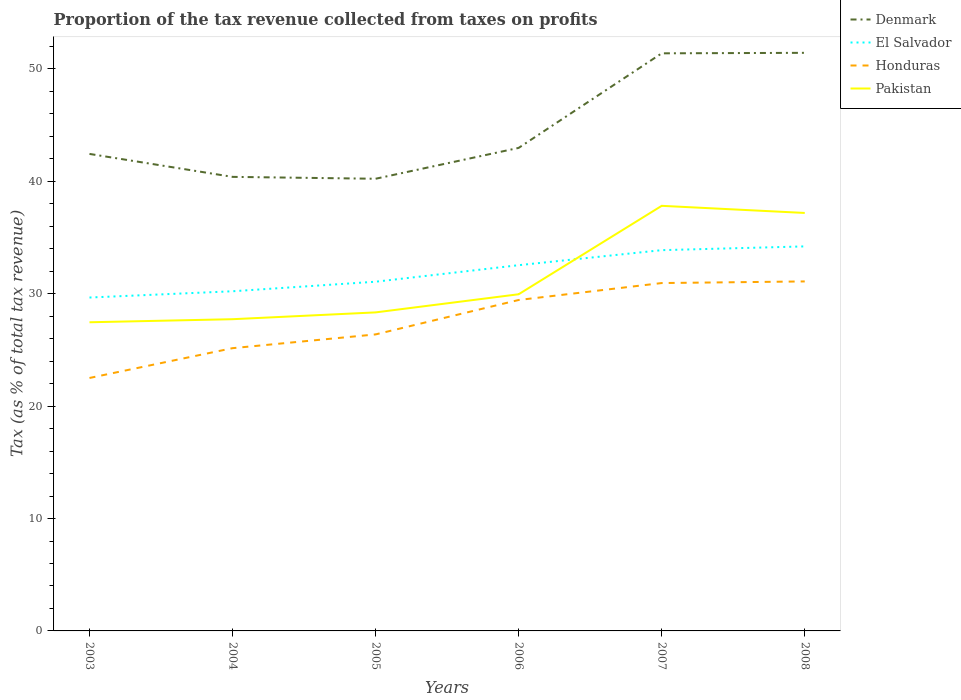How many different coloured lines are there?
Give a very brief answer. 4. Is the number of lines equal to the number of legend labels?
Keep it short and to the point. Yes. Across all years, what is the maximum proportion of the tax revenue collected in Honduras?
Give a very brief answer. 22.51. What is the total proportion of the tax revenue collected in Denmark in the graph?
Offer a very short reply. -8.41. What is the difference between the highest and the second highest proportion of the tax revenue collected in Honduras?
Keep it short and to the point. 8.59. Are the values on the major ticks of Y-axis written in scientific E-notation?
Your answer should be very brief. No. Does the graph contain grids?
Ensure brevity in your answer.  No. What is the title of the graph?
Your response must be concise. Proportion of the tax revenue collected from taxes on profits. Does "Colombia" appear as one of the legend labels in the graph?
Keep it short and to the point. No. What is the label or title of the X-axis?
Your answer should be compact. Years. What is the label or title of the Y-axis?
Keep it short and to the point. Tax (as % of total tax revenue). What is the Tax (as % of total tax revenue) in Denmark in 2003?
Keep it short and to the point. 42.44. What is the Tax (as % of total tax revenue) of El Salvador in 2003?
Provide a short and direct response. 29.66. What is the Tax (as % of total tax revenue) in Honduras in 2003?
Offer a very short reply. 22.51. What is the Tax (as % of total tax revenue) in Pakistan in 2003?
Your answer should be compact. 27.46. What is the Tax (as % of total tax revenue) in Denmark in 2004?
Your answer should be compact. 40.4. What is the Tax (as % of total tax revenue) in El Salvador in 2004?
Provide a short and direct response. 30.22. What is the Tax (as % of total tax revenue) of Honduras in 2004?
Offer a terse response. 25.16. What is the Tax (as % of total tax revenue) of Pakistan in 2004?
Provide a succinct answer. 27.74. What is the Tax (as % of total tax revenue) in Denmark in 2005?
Provide a succinct answer. 40.23. What is the Tax (as % of total tax revenue) in El Salvador in 2005?
Offer a terse response. 31.07. What is the Tax (as % of total tax revenue) in Honduras in 2005?
Your response must be concise. 26.38. What is the Tax (as % of total tax revenue) of Pakistan in 2005?
Your response must be concise. 28.34. What is the Tax (as % of total tax revenue) in Denmark in 2006?
Your answer should be very brief. 42.98. What is the Tax (as % of total tax revenue) in El Salvador in 2006?
Your answer should be compact. 32.54. What is the Tax (as % of total tax revenue) in Honduras in 2006?
Provide a succinct answer. 29.44. What is the Tax (as % of total tax revenue) in Pakistan in 2006?
Make the answer very short. 29.96. What is the Tax (as % of total tax revenue) of Denmark in 2007?
Keep it short and to the point. 51.39. What is the Tax (as % of total tax revenue) of El Salvador in 2007?
Ensure brevity in your answer.  33.88. What is the Tax (as % of total tax revenue) in Honduras in 2007?
Ensure brevity in your answer.  30.95. What is the Tax (as % of total tax revenue) of Pakistan in 2007?
Keep it short and to the point. 37.82. What is the Tax (as % of total tax revenue) of Denmark in 2008?
Your answer should be very brief. 51.44. What is the Tax (as % of total tax revenue) of El Salvador in 2008?
Give a very brief answer. 34.21. What is the Tax (as % of total tax revenue) of Honduras in 2008?
Ensure brevity in your answer.  31.1. What is the Tax (as % of total tax revenue) in Pakistan in 2008?
Ensure brevity in your answer.  37.19. Across all years, what is the maximum Tax (as % of total tax revenue) of Denmark?
Make the answer very short. 51.44. Across all years, what is the maximum Tax (as % of total tax revenue) of El Salvador?
Offer a terse response. 34.21. Across all years, what is the maximum Tax (as % of total tax revenue) of Honduras?
Your answer should be compact. 31.1. Across all years, what is the maximum Tax (as % of total tax revenue) in Pakistan?
Your answer should be compact. 37.82. Across all years, what is the minimum Tax (as % of total tax revenue) of Denmark?
Your response must be concise. 40.23. Across all years, what is the minimum Tax (as % of total tax revenue) of El Salvador?
Ensure brevity in your answer.  29.66. Across all years, what is the minimum Tax (as % of total tax revenue) in Honduras?
Keep it short and to the point. 22.51. Across all years, what is the minimum Tax (as % of total tax revenue) in Pakistan?
Provide a succinct answer. 27.46. What is the total Tax (as % of total tax revenue) in Denmark in the graph?
Give a very brief answer. 268.89. What is the total Tax (as % of total tax revenue) in El Salvador in the graph?
Offer a very short reply. 191.6. What is the total Tax (as % of total tax revenue) of Honduras in the graph?
Your answer should be compact. 165.54. What is the total Tax (as % of total tax revenue) in Pakistan in the graph?
Give a very brief answer. 188.51. What is the difference between the Tax (as % of total tax revenue) of Denmark in 2003 and that in 2004?
Provide a short and direct response. 2.04. What is the difference between the Tax (as % of total tax revenue) of El Salvador in 2003 and that in 2004?
Make the answer very short. -0.56. What is the difference between the Tax (as % of total tax revenue) of Honduras in 2003 and that in 2004?
Ensure brevity in your answer.  -2.65. What is the difference between the Tax (as % of total tax revenue) of Pakistan in 2003 and that in 2004?
Ensure brevity in your answer.  -0.27. What is the difference between the Tax (as % of total tax revenue) in Denmark in 2003 and that in 2005?
Keep it short and to the point. 2.21. What is the difference between the Tax (as % of total tax revenue) of El Salvador in 2003 and that in 2005?
Keep it short and to the point. -1.41. What is the difference between the Tax (as % of total tax revenue) of Honduras in 2003 and that in 2005?
Your answer should be compact. -3.88. What is the difference between the Tax (as % of total tax revenue) of Pakistan in 2003 and that in 2005?
Provide a succinct answer. -0.88. What is the difference between the Tax (as % of total tax revenue) of Denmark in 2003 and that in 2006?
Your answer should be compact. -0.54. What is the difference between the Tax (as % of total tax revenue) in El Salvador in 2003 and that in 2006?
Provide a succinct answer. -2.88. What is the difference between the Tax (as % of total tax revenue) of Honduras in 2003 and that in 2006?
Give a very brief answer. -6.94. What is the difference between the Tax (as % of total tax revenue) in Pakistan in 2003 and that in 2006?
Offer a terse response. -2.49. What is the difference between the Tax (as % of total tax revenue) in Denmark in 2003 and that in 2007?
Offer a very short reply. -8.95. What is the difference between the Tax (as % of total tax revenue) of El Salvador in 2003 and that in 2007?
Make the answer very short. -4.22. What is the difference between the Tax (as % of total tax revenue) in Honduras in 2003 and that in 2007?
Offer a terse response. -8.45. What is the difference between the Tax (as % of total tax revenue) of Pakistan in 2003 and that in 2007?
Offer a very short reply. -10.36. What is the difference between the Tax (as % of total tax revenue) in Denmark in 2003 and that in 2008?
Offer a terse response. -8.99. What is the difference between the Tax (as % of total tax revenue) in El Salvador in 2003 and that in 2008?
Keep it short and to the point. -4.55. What is the difference between the Tax (as % of total tax revenue) of Honduras in 2003 and that in 2008?
Offer a terse response. -8.59. What is the difference between the Tax (as % of total tax revenue) in Pakistan in 2003 and that in 2008?
Provide a short and direct response. -9.73. What is the difference between the Tax (as % of total tax revenue) of Denmark in 2004 and that in 2005?
Provide a short and direct response. 0.17. What is the difference between the Tax (as % of total tax revenue) of El Salvador in 2004 and that in 2005?
Keep it short and to the point. -0.85. What is the difference between the Tax (as % of total tax revenue) of Honduras in 2004 and that in 2005?
Ensure brevity in your answer.  -1.22. What is the difference between the Tax (as % of total tax revenue) in Pakistan in 2004 and that in 2005?
Your answer should be compact. -0.61. What is the difference between the Tax (as % of total tax revenue) of Denmark in 2004 and that in 2006?
Keep it short and to the point. -2.58. What is the difference between the Tax (as % of total tax revenue) of El Salvador in 2004 and that in 2006?
Offer a very short reply. -2.32. What is the difference between the Tax (as % of total tax revenue) of Honduras in 2004 and that in 2006?
Offer a terse response. -4.29. What is the difference between the Tax (as % of total tax revenue) of Pakistan in 2004 and that in 2006?
Provide a short and direct response. -2.22. What is the difference between the Tax (as % of total tax revenue) of Denmark in 2004 and that in 2007?
Offer a terse response. -10.99. What is the difference between the Tax (as % of total tax revenue) of El Salvador in 2004 and that in 2007?
Your answer should be very brief. -3.66. What is the difference between the Tax (as % of total tax revenue) of Honduras in 2004 and that in 2007?
Your response must be concise. -5.79. What is the difference between the Tax (as % of total tax revenue) in Pakistan in 2004 and that in 2007?
Give a very brief answer. -10.09. What is the difference between the Tax (as % of total tax revenue) of Denmark in 2004 and that in 2008?
Give a very brief answer. -11.04. What is the difference between the Tax (as % of total tax revenue) in El Salvador in 2004 and that in 2008?
Keep it short and to the point. -3.99. What is the difference between the Tax (as % of total tax revenue) in Honduras in 2004 and that in 2008?
Ensure brevity in your answer.  -5.94. What is the difference between the Tax (as % of total tax revenue) in Pakistan in 2004 and that in 2008?
Your answer should be very brief. -9.45. What is the difference between the Tax (as % of total tax revenue) in Denmark in 2005 and that in 2006?
Make the answer very short. -2.75. What is the difference between the Tax (as % of total tax revenue) of El Salvador in 2005 and that in 2006?
Offer a very short reply. -1.47. What is the difference between the Tax (as % of total tax revenue) of Honduras in 2005 and that in 2006?
Ensure brevity in your answer.  -3.06. What is the difference between the Tax (as % of total tax revenue) of Pakistan in 2005 and that in 2006?
Provide a short and direct response. -1.61. What is the difference between the Tax (as % of total tax revenue) of Denmark in 2005 and that in 2007?
Make the answer very short. -11.16. What is the difference between the Tax (as % of total tax revenue) of El Salvador in 2005 and that in 2007?
Your answer should be very brief. -2.81. What is the difference between the Tax (as % of total tax revenue) of Honduras in 2005 and that in 2007?
Your answer should be compact. -4.57. What is the difference between the Tax (as % of total tax revenue) of Pakistan in 2005 and that in 2007?
Provide a short and direct response. -9.48. What is the difference between the Tax (as % of total tax revenue) of Denmark in 2005 and that in 2008?
Provide a short and direct response. -11.2. What is the difference between the Tax (as % of total tax revenue) of El Salvador in 2005 and that in 2008?
Provide a succinct answer. -3.14. What is the difference between the Tax (as % of total tax revenue) in Honduras in 2005 and that in 2008?
Offer a terse response. -4.71. What is the difference between the Tax (as % of total tax revenue) in Pakistan in 2005 and that in 2008?
Ensure brevity in your answer.  -8.85. What is the difference between the Tax (as % of total tax revenue) of Denmark in 2006 and that in 2007?
Keep it short and to the point. -8.41. What is the difference between the Tax (as % of total tax revenue) of El Salvador in 2006 and that in 2007?
Your answer should be very brief. -1.34. What is the difference between the Tax (as % of total tax revenue) in Honduras in 2006 and that in 2007?
Offer a very short reply. -1.51. What is the difference between the Tax (as % of total tax revenue) in Pakistan in 2006 and that in 2007?
Your answer should be compact. -7.87. What is the difference between the Tax (as % of total tax revenue) in Denmark in 2006 and that in 2008?
Offer a terse response. -8.46. What is the difference between the Tax (as % of total tax revenue) of El Salvador in 2006 and that in 2008?
Ensure brevity in your answer.  -1.67. What is the difference between the Tax (as % of total tax revenue) of Honduras in 2006 and that in 2008?
Your answer should be compact. -1.65. What is the difference between the Tax (as % of total tax revenue) of Pakistan in 2006 and that in 2008?
Make the answer very short. -7.23. What is the difference between the Tax (as % of total tax revenue) of Denmark in 2007 and that in 2008?
Your answer should be compact. -0.04. What is the difference between the Tax (as % of total tax revenue) of El Salvador in 2007 and that in 2008?
Make the answer very short. -0.33. What is the difference between the Tax (as % of total tax revenue) in Honduras in 2007 and that in 2008?
Ensure brevity in your answer.  -0.15. What is the difference between the Tax (as % of total tax revenue) in Pakistan in 2007 and that in 2008?
Your answer should be compact. 0.63. What is the difference between the Tax (as % of total tax revenue) of Denmark in 2003 and the Tax (as % of total tax revenue) of El Salvador in 2004?
Offer a terse response. 12.22. What is the difference between the Tax (as % of total tax revenue) of Denmark in 2003 and the Tax (as % of total tax revenue) of Honduras in 2004?
Your response must be concise. 17.28. What is the difference between the Tax (as % of total tax revenue) in Denmark in 2003 and the Tax (as % of total tax revenue) in Pakistan in 2004?
Your answer should be very brief. 14.71. What is the difference between the Tax (as % of total tax revenue) of El Salvador in 2003 and the Tax (as % of total tax revenue) of Honduras in 2004?
Give a very brief answer. 4.51. What is the difference between the Tax (as % of total tax revenue) in El Salvador in 2003 and the Tax (as % of total tax revenue) in Pakistan in 2004?
Keep it short and to the point. 1.93. What is the difference between the Tax (as % of total tax revenue) in Honduras in 2003 and the Tax (as % of total tax revenue) in Pakistan in 2004?
Your answer should be compact. -5.23. What is the difference between the Tax (as % of total tax revenue) in Denmark in 2003 and the Tax (as % of total tax revenue) in El Salvador in 2005?
Keep it short and to the point. 11.37. What is the difference between the Tax (as % of total tax revenue) of Denmark in 2003 and the Tax (as % of total tax revenue) of Honduras in 2005?
Your response must be concise. 16.06. What is the difference between the Tax (as % of total tax revenue) of Denmark in 2003 and the Tax (as % of total tax revenue) of Pakistan in 2005?
Offer a very short reply. 14.1. What is the difference between the Tax (as % of total tax revenue) in El Salvador in 2003 and the Tax (as % of total tax revenue) in Honduras in 2005?
Make the answer very short. 3.28. What is the difference between the Tax (as % of total tax revenue) in El Salvador in 2003 and the Tax (as % of total tax revenue) in Pakistan in 2005?
Offer a very short reply. 1.32. What is the difference between the Tax (as % of total tax revenue) of Honduras in 2003 and the Tax (as % of total tax revenue) of Pakistan in 2005?
Ensure brevity in your answer.  -5.84. What is the difference between the Tax (as % of total tax revenue) of Denmark in 2003 and the Tax (as % of total tax revenue) of El Salvador in 2006?
Provide a succinct answer. 9.9. What is the difference between the Tax (as % of total tax revenue) in Denmark in 2003 and the Tax (as % of total tax revenue) in Honduras in 2006?
Your answer should be very brief. 13. What is the difference between the Tax (as % of total tax revenue) in Denmark in 2003 and the Tax (as % of total tax revenue) in Pakistan in 2006?
Keep it short and to the point. 12.49. What is the difference between the Tax (as % of total tax revenue) in El Salvador in 2003 and the Tax (as % of total tax revenue) in Honduras in 2006?
Keep it short and to the point. 0.22. What is the difference between the Tax (as % of total tax revenue) in El Salvador in 2003 and the Tax (as % of total tax revenue) in Pakistan in 2006?
Offer a terse response. -0.29. What is the difference between the Tax (as % of total tax revenue) in Honduras in 2003 and the Tax (as % of total tax revenue) in Pakistan in 2006?
Your answer should be very brief. -7.45. What is the difference between the Tax (as % of total tax revenue) in Denmark in 2003 and the Tax (as % of total tax revenue) in El Salvador in 2007?
Make the answer very short. 8.56. What is the difference between the Tax (as % of total tax revenue) of Denmark in 2003 and the Tax (as % of total tax revenue) of Honduras in 2007?
Give a very brief answer. 11.49. What is the difference between the Tax (as % of total tax revenue) of Denmark in 2003 and the Tax (as % of total tax revenue) of Pakistan in 2007?
Make the answer very short. 4.62. What is the difference between the Tax (as % of total tax revenue) in El Salvador in 2003 and the Tax (as % of total tax revenue) in Honduras in 2007?
Your answer should be compact. -1.29. What is the difference between the Tax (as % of total tax revenue) of El Salvador in 2003 and the Tax (as % of total tax revenue) of Pakistan in 2007?
Keep it short and to the point. -8.16. What is the difference between the Tax (as % of total tax revenue) of Honduras in 2003 and the Tax (as % of total tax revenue) of Pakistan in 2007?
Your answer should be very brief. -15.32. What is the difference between the Tax (as % of total tax revenue) in Denmark in 2003 and the Tax (as % of total tax revenue) in El Salvador in 2008?
Your answer should be compact. 8.23. What is the difference between the Tax (as % of total tax revenue) of Denmark in 2003 and the Tax (as % of total tax revenue) of Honduras in 2008?
Provide a short and direct response. 11.35. What is the difference between the Tax (as % of total tax revenue) in Denmark in 2003 and the Tax (as % of total tax revenue) in Pakistan in 2008?
Your response must be concise. 5.25. What is the difference between the Tax (as % of total tax revenue) of El Salvador in 2003 and the Tax (as % of total tax revenue) of Honduras in 2008?
Ensure brevity in your answer.  -1.43. What is the difference between the Tax (as % of total tax revenue) of El Salvador in 2003 and the Tax (as % of total tax revenue) of Pakistan in 2008?
Ensure brevity in your answer.  -7.53. What is the difference between the Tax (as % of total tax revenue) of Honduras in 2003 and the Tax (as % of total tax revenue) of Pakistan in 2008?
Provide a succinct answer. -14.68. What is the difference between the Tax (as % of total tax revenue) in Denmark in 2004 and the Tax (as % of total tax revenue) in El Salvador in 2005?
Give a very brief answer. 9.33. What is the difference between the Tax (as % of total tax revenue) in Denmark in 2004 and the Tax (as % of total tax revenue) in Honduras in 2005?
Keep it short and to the point. 14.02. What is the difference between the Tax (as % of total tax revenue) of Denmark in 2004 and the Tax (as % of total tax revenue) of Pakistan in 2005?
Your answer should be compact. 12.06. What is the difference between the Tax (as % of total tax revenue) of El Salvador in 2004 and the Tax (as % of total tax revenue) of Honduras in 2005?
Provide a short and direct response. 3.84. What is the difference between the Tax (as % of total tax revenue) in El Salvador in 2004 and the Tax (as % of total tax revenue) in Pakistan in 2005?
Offer a very short reply. 1.88. What is the difference between the Tax (as % of total tax revenue) of Honduras in 2004 and the Tax (as % of total tax revenue) of Pakistan in 2005?
Your answer should be compact. -3.18. What is the difference between the Tax (as % of total tax revenue) in Denmark in 2004 and the Tax (as % of total tax revenue) in El Salvador in 2006?
Make the answer very short. 7.86. What is the difference between the Tax (as % of total tax revenue) of Denmark in 2004 and the Tax (as % of total tax revenue) of Honduras in 2006?
Your answer should be compact. 10.96. What is the difference between the Tax (as % of total tax revenue) in Denmark in 2004 and the Tax (as % of total tax revenue) in Pakistan in 2006?
Your answer should be compact. 10.45. What is the difference between the Tax (as % of total tax revenue) in El Salvador in 2004 and the Tax (as % of total tax revenue) in Honduras in 2006?
Give a very brief answer. 0.78. What is the difference between the Tax (as % of total tax revenue) in El Salvador in 2004 and the Tax (as % of total tax revenue) in Pakistan in 2006?
Give a very brief answer. 0.27. What is the difference between the Tax (as % of total tax revenue) of Honduras in 2004 and the Tax (as % of total tax revenue) of Pakistan in 2006?
Provide a succinct answer. -4.8. What is the difference between the Tax (as % of total tax revenue) in Denmark in 2004 and the Tax (as % of total tax revenue) in El Salvador in 2007?
Ensure brevity in your answer.  6.52. What is the difference between the Tax (as % of total tax revenue) of Denmark in 2004 and the Tax (as % of total tax revenue) of Honduras in 2007?
Provide a succinct answer. 9.45. What is the difference between the Tax (as % of total tax revenue) of Denmark in 2004 and the Tax (as % of total tax revenue) of Pakistan in 2007?
Your answer should be compact. 2.58. What is the difference between the Tax (as % of total tax revenue) of El Salvador in 2004 and the Tax (as % of total tax revenue) of Honduras in 2007?
Provide a short and direct response. -0.73. What is the difference between the Tax (as % of total tax revenue) of El Salvador in 2004 and the Tax (as % of total tax revenue) of Pakistan in 2007?
Your answer should be compact. -7.6. What is the difference between the Tax (as % of total tax revenue) in Honduras in 2004 and the Tax (as % of total tax revenue) in Pakistan in 2007?
Offer a terse response. -12.67. What is the difference between the Tax (as % of total tax revenue) in Denmark in 2004 and the Tax (as % of total tax revenue) in El Salvador in 2008?
Your answer should be very brief. 6.19. What is the difference between the Tax (as % of total tax revenue) in Denmark in 2004 and the Tax (as % of total tax revenue) in Honduras in 2008?
Provide a succinct answer. 9.3. What is the difference between the Tax (as % of total tax revenue) in Denmark in 2004 and the Tax (as % of total tax revenue) in Pakistan in 2008?
Offer a terse response. 3.21. What is the difference between the Tax (as % of total tax revenue) of El Salvador in 2004 and the Tax (as % of total tax revenue) of Honduras in 2008?
Offer a terse response. -0.88. What is the difference between the Tax (as % of total tax revenue) of El Salvador in 2004 and the Tax (as % of total tax revenue) of Pakistan in 2008?
Ensure brevity in your answer.  -6.97. What is the difference between the Tax (as % of total tax revenue) in Honduras in 2004 and the Tax (as % of total tax revenue) in Pakistan in 2008?
Make the answer very short. -12.03. What is the difference between the Tax (as % of total tax revenue) of Denmark in 2005 and the Tax (as % of total tax revenue) of El Salvador in 2006?
Give a very brief answer. 7.69. What is the difference between the Tax (as % of total tax revenue) in Denmark in 2005 and the Tax (as % of total tax revenue) in Honduras in 2006?
Your answer should be very brief. 10.79. What is the difference between the Tax (as % of total tax revenue) of Denmark in 2005 and the Tax (as % of total tax revenue) of Pakistan in 2006?
Offer a very short reply. 10.28. What is the difference between the Tax (as % of total tax revenue) in El Salvador in 2005 and the Tax (as % of total tax revenue) in Honduras in 2006?
Your answer should be compact. 1.63. What is the difference between the Tax (as % of total tax revenue) of El Salvador in 2005 and the Tax (as % of total tax revenue) of Pakistan in 2006?
Provide a succinct answer. 1.12. What is the difference between the Tax (as % of total tax revenue) of Honduras in 2005 and the Tax (as % of total tax revenue) of Pakistan in 2006?
Make the answer very short. -3.57. What is the difference between the Tax (as % of total tax revenue) of Denmark in 2005 and the Tax (as % of total tax revenue) of El Salvador in 2007?
Your answer should be very brief. 6.35. What is the difference between the Tax (as % of total tax revenue) of Denmark in 2005 and the Tax (as % of total tax revenue) of Honduras in 2007?
Make the answer very short. 9.28. What is the difference between the Tax (as % of total tax revenue) in Denmark in 2005 and the Tax (as % of total tax revenue) in Pakistan in 2007?
Offer a very short reply. 2.41. What is the difference between the Tax (as % of total tax revenue) of El Salvador in 2005 and the Tax (as % of total tax revenue) of Honduras in 2007?
Your answer should be very brief. 0.12. What is the difference between the Tax (as % of total tax revenue) of El Salvador in 2005 and the Tax (as % of total tax revenue) of Pakistan in 2007?
Your answer should be compact. -6.75. What is the difference between the Tax (as % of total tax revenue) in Honduras in 2005 and the Tax (as % of total tax revenue) in Pakistan in 2007?
Keep it short and to the point. -11.44. What is the difference between the Tax (as % of total tax revenue) in Denmark in 2005 and the Tax (as % of total tax revenue) in El Salvador in 2008?
Your answer should be compact. 6.02. What is the difference between the Tax (as % of total tax revenue) in Denmark in 2005 and the Tax (as % of total tax revenue) in Honduras in 2008?
Your response must be concise. 9.13. What is the difference between the Tax (as % of total tax revenue) in Denmark in 2005 and the Tax (as % of total tax revenue) in Pakistan in 2008?
Offer a terse response. 3.04. What is the difference between the Tax (as % of total tax revenue) in El Salvador in 2005 and the Tax (as % of total tax revenue) in Honduras in 2008?
Give a very brief answer. -0.03. What is the difference between the Tax (as % of total tax revenue) of El Salvador in 2005 and the Tax (as % of total tax revenue) of Pakistan in 2008?
Your response must be concise. -6.12. What is the difference between the Tax (as % of total tax revenue) in Honduras in 2005 and the Tax (as % of total tax revenue) in Pakistan in 2008?
Keep it short and to the point. -10.81. What is the difference between the Tax (as % of total tax revenue) of Denmark in 2006 and the Tax (as % of total tax revenue) of El Salvador in 2007?
Your answer should be compact. 9.1. What is the difference between the Tax (as % of total tax revenue) of Denmark in 2006 and the Tax (as % of total tax revenue) of Honduras in 2007?
Make the answer very short. 12.03. What is the difference between the Tax (as % of total tax revenue) in Denmark in 2006 and the Tax (as % of total tax revenue) in Pakistan in 2007?
Ensure brevity in your answer.  5.16. What is the difference between the Tax (as % of total tax revenue) in El Salvador in 2006 and the Tax (as % of total tax revenue) in Honduras in 2007?
Ensure brevity in your answer.  1.59. What is the difference between the Tax (as % of total tax revenue) in El Salvador in 2006 and the Tax (as % of total tax revenue) in Pakistan in 2007?
Offer a very short reply. -5.28. What is the difference between the Tax (as % of total tax revenue) of Honduras in 2006 and the Tax (as % of total tax revenue) of Pakistan in 2007?
Make the answer very short. -8.38. What is the difference between the Tax (as % of total tax revenue) of Denmark in 2006 and the Tax (as % of total tax revenue) of El Salvador in 2008?
Provide a succinct answer. 8.76. What is the difference between the Tax (as % of total tax revenue) in Denmark in 2006 and the Tax (as % of total tax revenue) in Honduras in 2008?
Provide a short and direct response. 11.88. What is the difference between the Tax (as % of total tax revenue) of Denmark in 2006 and the Tax (as % of total tax revenue) of Pakistan in 2008?
Ensure brevity in your answer.  5.79. What is the difference between the Tax (as % of total tax revenue) of El Salvador in 2006 and the Tax (as % of total tax revenue) of Honduras in 2008?
Give a very brief answer. 1.44. What is the difference between the Tax (as % of total tax revenue) in El Salvador in 2006 and the Tax (as % of total tax revenue) in Pakistan in 2008?
Give a very brief answer. -4.65. What is the difference between the Tax (as % of total tax revenue) in Honduras in 2006 and the Tax (as % of total tax revenue) in Pakistan in 2008?
Make the answer very short. -7.74. What is the difference between the Tax (as % of total tax revenue) in Denmark in 2007 and the Tax (as % of total tax revenue) in El Salvador in 2008?
Make the answer very short. 17.18. What is the difference between the Tax (as % of total tax revenue) of Denmark in 2007 and the Tax (as % of total tax revenue) of Honduras in 2008?
Provide a succinct answer. 20.3. What is the difference between the Tax (as % of total tax revenue) in Denmark in 2007 and the Tax (as % of total tax revenue) in Pakistan in 2008?
Your response must be concise. 14.2. What is the difference between the Tax (as % of total tax revenue) in El Salvador in 2007 and the Tax (as % of total tax revenue) in Honduras in 2008?
Your answer should be very brief. 2.78. What is the difference between the Tax (as % of total tax revenue) in El Salvador in 2007 and the Tax (as % of total tax revenue) in Pakistan in 2008?
Keep it short and to the point. -3.31. What is the difference between the Tax (as % of total tax revenue) of Honduras in 2007 and the Tax (as % of total tax revenue) of Pakistan in 2008?
Your answer should be compact. -6.24. What is the average Tax (as % of total tax revenue) in Denmark per year?
Your answer should be very brief. 44.81. What is the average Tax (as % of total tax revenue) of El Salvador per year?
Your answer should be very brief. 31.93. What is the average Tax (as % of total tax revenue) in Honduras per year?
Ensure brevity in your answer.  27.59. What is the average Tax (as % of total tax revenue) in Pakistan per year?
Provide a succinct answer. 31.42. In the year 2003, what is the difference between the Tax (as % of total tax revenue) in Denmark and Tax (as % of total tax revenue) in El Salvador?
Offer a very short reply. 12.78. In the year 2003, what is the difference between the Tax (as % of total tax revenue) of Denmark and Tax (as % of total tax revenue) of Honduras?
Make the answer very short. 19.94. In the year 2003, what is the difference between the Tax (as % of total tax revenue) in Denmark and Tax (as % of total tax revenue) in Pakistan?
Provide a succinct answer. 14.98. In the year 2003, what is the difference between the Tax (as % of total tax revenue) in El Salvador and Tax (as % of total tax revenue) in Honduras?
Keep it short and to the point. 7.16. In the year 2003, what is the difference between the Tax (as % of total tax revenue) in El Salvador and Tax (as % of total tax revenue) in Pakistan?
Make the answer very short. 2.2. In the year 2003, what is the difference between the Tax (as % of total tax revenue) of Honduras and Tax (as % of total tax revenue) of Pakistan?
Provide a short and direct response. -4.96. In the year 2004, what is the difference between the Tax (as % of total tax revenue) of Denmark and Tax (as % of total tax revenue) of El Salvador?
Make the answer very short. 10.18. In the year 2004, what is the difference between the Tax (as % of total tax revenue) of Denmark and Tax (as % of total tax revenue) of Honduras?
Your response must be concise. 15.24. In the year 2004, what is the difference between the Tax (as % of total tax revenue) in Denmark and Tax (as % of total tax revenue) in Pakistan?
Your answer should be compact. 12.66. In the year 2004, what is the difference between the Tax (as % of total tax revenue) of El Salvador and Tax (as % of total tax revenue) of Honduras?
Ensure brevity in your answer.  5.06. In the year 2004, what is the difference between the Tax (as % of total tax revenue) of El Salvador and Tax (as % of total tax revenue) of Pakistan?
Your answer should be compact. 2.49. In the year 2004, what is the difference between the Tax (as % of total tax revenue) of Honduras and Tax (as % of total tax revenue) of Pakistan?
Provide a succinct answer. -2.58. In the year 2005, what is the difference between the Tax (as % of total tax revenue) of Denmark and Tax (as % of total tax revenue) of El Salvador?
Provide a short and direct response. 9.16. In the year 2005, what is the difference between the Tax (as % of total tax revenue) in Denmark and Tax (as % of total tax revenue) in Honduras?
Provide a short and direct response. 13.85. In the year 2005, what is the difference between the Tax (as % of total tax revenue) in Denmark and Tax (as % of total tax revenue) in Pakistan?
Ensure brevity in your answer.  11.89. In the year 2005, what is the difference between the Tax (as % of total tax revenue) of El Salvador and Tax (as % of total tax revenue) of Honduras?
Offer a very short reply. 4.69. In the year 2005, what is the difference between the Tax (as % of total tax revenue) in El Salvador and Tax (as % of total tax revenue) in Pakistan?
Provide a short and direct response. 2.73. In the year 2005, what is the difference between the Tax (as % of total tax revenue) of Honduras and Tax (as % of total tax revenue) of Pakistan?
Keep it short and to the point. -1.96. In the year 2006, what is the difference between the Tax (as % of total tax revenue) in Denmark and Tax (as % of total tax revenue) in El Salvador?
Provide a succinct answer. 10.44. In the year 2006, what is the difference between the Tax (as % of total tax revenue) of Denmark and Tax (as % of total tax revenue) of Honduras?
Offer a very short reply. 13.53. In the year 2006, what is the difference between the Tax (as % of total tax revenue) in Denmark and Tax (as % of total tax revenue) in Pakistan?
Keep it short and to the point. 13.02. In the year 2006, what is the difference between the Tax (as % of total tax revenue) in El Salvador and Tax (as % of total tax revenue) in Honduras?
Offer a very short reply. 3.1. In the year 2006, what is the difference between the Tax (as % of total tax revenue) in El Salvador and Tax (as % of total tax revenue) in Pakistan?
Offer a terse response. 2.59. In the year 2006, what is the difference between the Tax (as % of total tax revenue) of Honduras and Tax (as % of total tax revenue) of Pakistan?
Make the answer very short. -0.51. In the year 2007, what is the difference between the Tax (as % of total tax revenue) in Denmark and Tax (as % of total tax revenue) in El Salvador?
Offer a very short reply. 17.51. In the year 2007, what is the difference between the Tax (as % of total tax revenue) in Denmark and Tax (as % of total tax revenue) in Honduras?
Give a very brief answer. 20.44. In the year 2007, what is the difference between the Tax (as % of total tax revenue) in Denmark and Tax (as % of total tax revenue) in Pakistan?
Your answer should be very brief. 13.57. In the year 2007, what is the difference between the Tax (as % of total tax revenue) in El Salvador and Tax (as % of total tax revenue) in Honduras?
Your answer should be compact. 2.93. In the year 2007, what is the difference between the Tax (as % of total tax revenue) of El Salvador and Tax (as % of total tax revenue) of Pakistan?
Give a very brief answer. -3.94. In the year 2007, what is the difference between the Tax (as % of total tax revenue) in Honduras and Tax (as % of total tax revenue) in Pakistan?
Your response must be concise. -6.87. In the year 2008, what is the difference between the Tax (as % of total tax revenue) in Denmark and Tax (as % of total tax revenue) in El Salvador?
Ensure brevity in your answer.  17.22. In the year 2008, what is the difference between the Tax (as % of total tax revenue) of Denmark and Tax (as % of total tax revenue) of Honduras?
Offer a very short reply. 20.34. In the year 2008, what is the difference between the Tax (as % of total tax revenue) in Denmark and Tax (as % of total tax revenue) in Pakistan?
Provide a short and direct response. 14.25. In the year 2008, what is the difference between the Tax (as % of total tax revenue) of El Salvador and Tax (as % of total tax revenue) of Honduras?
Make the answer very short. 3.12. In the year 2008, what is the difference between the Tax (as % of total tax revenue) in El Salvador and Tax (as % of total tax revenue) in Pakistan?
Ensure brevity in your answer.  -2.98. In the year 2008, what is the difference between the Tax (as % of total tax revenue) in Honduras and Tax (as % of total tax revenue) in Pakistan?
Offer a terse response. -6.09. What is the ratio of the Tax (as % of total tax revenue) of Denmark in 2003 to that in 2004?
Offer a terse response. 1.05. What is the ratio of the Tax (as % of total tax revenue) of El Salvador in 2003 to that in 2004?
Offer a terse response. 0.98. What is the ratio of the Tax (as % of total tax revenue) in Honduras in 2003 to that in 2004?
Give a very brief answer. 0.89. What is the ratio of the Tax (as % of total tax revenue) in Pakistan in 2003 to that in 2004?
Make the answer very short. 0.99. What is the ratio of the Tax (as % of total tax revenue) in Denmark in 2003 to that in 2005?
Provide a short and direct response. 1.05. What is the ratio of the Tax (as % of total tax revenue) in El Salvador in 2003 to that in 2005?
Make the answer very short. 0.95. What is the ratio of the Tax (as % of total tax revenue) in Honduras in 2003 to that in 2005?
Provide a short and direct response. 0.85. What is the ratio of the Tax (as % of total tax revenue) in Pakistan in 2003 to that in 2005?
Your answer should be compact. 0.97. What is the ratio of the Tax (as % of total tax revenue) of Denmark in 2003 to that in 2006?
Offer a very short reply. 0.99. What is the ratio of the Tax (as % of total tax revenue) of El Salvador in 2003 to that in 2006?
Provide a succinct answer. 0.91. What is the ratio of the Tax (as % of total tax revenue) of Honduras in 2003 to that in 2006?
Keep it short and to the point. 0.76. What is the ratio of the Tax (as % of total tax revenue) of Pakistan in 2003 to that in 2006?
Give a very brief answer. 0.92. What is the ratio of the Tax (as % of total tax revenue) in Denmark in 2003 to that in 2007?
Offer a very short reply. 0.83. What is the ratio of the Tax (as % of total tax revenue) of El Salvador in 2003 to that in 2007?
Your answer should be very brief. 0.88. What is the ratio of the Tax (as % of total tax revenue) of Honduras in 2003 to that in 2007?
Ensure brevity in your answer.  0.73. What is the ratio of the Tax (as % of total tax revenue) in Pakistan in 2003 to that in 2007?
Ensure brevity in your answer.  0.73. What is the ratio of the Tax (as % of total tax revenue) in Denmark in 2003 to that in 2008?
Keep it short and to the point. 0.83. What is the ratio of the Tax (as % of total tax revenue) in El Salvador in 2003 to that in 2008?
Offer a very short reply. 0.87. What is the ratio of the Tax (as % of total tax revenue) of Honduras in 2003 to that in 2008?
Your answer should be very brief. 0.72. What is the ratio of the Tax (as % of total tax revenue) in Pakistan in 2003 to that in 2008?
Ensure brevity in your answer.  0.74. What is the ratio of the Tax (as % of total tax revenue) in El Salvador in 2004 to that in 2005?
Keep it short and to the point. 0.97. What is the ratio of the Tax (as % of total tax revenue) in Honduras in 2004 to that in 2005?
Your response must be concise. 0.95. What is the ratio of the Tax (as % of total tax revenue) of Pakistan in 2004 to that in 2005?
Give a very brief answer. 0.98. What is the ratio of the Tax (as % of total tax revenue) in El Salvador in 2004 to that in 2006?
Make the answer very short. 0.93. What is the ratio of the Tax (as % of total tax revenue) of Honduras in 2004 to that in 2006?
Keep it short and to the point. 0.85. What is the ratio of the Tax (as % of total tax revenue) of Pakistan in 2004 to that in 2006?
Offer a very short reply. 0.93. What is the ratio of the Tax (as % of total tax revenue) in Denmark in 2004 to that in 2007?
Make the answer very short. 0.79. What is the ratio of the Tax (as % of total tax revenue) of El Salvador in 2004 to that in 2007?
Provide a short and direct response. 0.89. What is the ratio of the Tax (as % of total tax revenue) in Honduras in 2004 to that in 2007?
Offer a terse response. 0.81. What is the ratio of the Tax (as % of total tax revenue) in Pakistan in 2004 to that in 2007?
Provide a short and direct response. 0.73. What is the ratio of the Tax (as % of total tax revenue) in Denmark in 2004 to that in 2008?
Offer a terse response. 0.79. What is the ratio of the Tax (as % of total tax revenue) in El Salvador in 2004 to that in 2008?
Your answer should be very brief. 0.88. What is the ratio of the Tax (as % of total tax revenue) of Honduras in 2004 to that in 2008?
Make the answer very short. 0.81. What is the ratio of the Tax (as % of total tax revenue) in Pakistan in 2004 to that in 2008?
Offer a terse response. 0.75. What is the ratio of the Tax (as % of total tax revenue) of Denmark in 2005 to that in 2006?
Your response must be concise. 0.94. What is the ratio of the Tax (as % of total tax revenue) of El Salvador in 2005 to that in 2006?
Keep it short and to the point. 0.95. What is the ratio of the Tax (as % of total tax revenue) of Honduras in 2005 to that in 2006?
Provide a short and direct response. 0.9. What is the ratio of the Tax (as % of total tax revenue) of Pakistan in 2005 to that in 2006?
Offer a very short reply. 0.95. What is the ratio of the Tax (as % of total tax revenue) in Denmark in 2005 to that in 2007?
Your answer should be compact. 0.78. What is the ratio of the Tax (as % of total tax revenue) in El Salvador in 2005 to that in 2007?
Your answer should be very brief. 0.92. What is the ratio of the Tax (as % of total tax revenue) in Honduras in 2005 to that in 2007?
Provide a short and direct response. 0.85. What is the ratio of the Tax (as % of total tax revenue) of Pakistan in 2005 to that in 2007?
Offer a very short reply. 0.75. What is the ratio of the Tax (as % of total tax revenue) of Denmark in 2005 to that in 2008?
Keep it short and to the point. 0.78. What is the ratio of the Tax (as % of total tax revenue) in El Salvador in 2005 to that in 2008?
Offer a terse response. 0.91. What is the ratio of the Tax (as % of total tax revenue) of Honduras in 2005 to that in 2008?
Give a very brief answer. 0.85. What is the ratio of the Tax (as % of total tax revenue) of Pakistan in 2005 to that in 2008?
Your answer should be very brief. 0.76. What is the ratio of the Tax (as % of total tax revenue) of Denmark in 2006 to that in 2007?
Provide a short and direct response. 0.84. What is the ratio of the Tax (as % of total tax revenue) in El Salvador in 2006 to that in 2007?
Your answer should be compact. 0.96. What is the ratio of the Tax (as % of total tax revenue) of Honduras in 2006 to that in 2007?
Your answer should be very brief. 0.95. What is the ratio of the Tax (as % of total tax revenue) in Pakistan in 2006 to that in 2007?
Your answer should be very brief. 0.79. What is the ratio of the Tax (as % of total tax revenue) of Denmark in 2006 to that in 2008?
Provide a short and direct response. 0.84. What is the ratio of the Tax (as % of total tax revenue) in El Salvador in 2006 to that in 2008?
Your response must be concise. 0.95. What is the ratio of the Tax (as % of total tax revenue) of Honduras in 2006 to that in 2008?
Your response must be concise. 0.95. What is the ratio of the Tax (as % of total tax revenue) of Pakistan in 2006 to that in 2008?
Your answer should be very brief. 0.81. What is the ratio of the Tax (as % of total tax revenue) of El Salvador in 2007 to that in 2008?
Your answer should be very brief. 0.99. What is the ratio of the Tax (as % of total tax revenue) in Honduras in 2007 to that in 2008?
Make the answer very short. 1. What is the ratio of the Tax (as % of total tax revenue) of Pakistan in 2007 to that in 2008?
Give a very brief answer. 1.02. What is the difference between the highest and the second highest Tax (as % of total tax revenue) of Denmark?
Your answer should be very brief. 0.04. What is the difference between the highest and the second highest Tax (as % of total tax revenue) of El Salvador?
Offer a very short reply. 0.33. What is the difference between the highest and the second highest Tax (as % of total tax revenue) of Honduras?
Make the answer very short. 0.15. What is the difference between the highest and the second highest Tax (as % of total tax revenue) of Pakistan?
Your answer should be very brief. 0.63. What is the difference between the highest and the lowest Tax (as % of total tax revenue) in Denmark?
Keep it short and to the point. 11.2. What is the difference between the highest and the lowest Tax (as % of total tax revenue) in El Salvador?
Provide a short and direct response. 4.55. What is the difference between the highest and the lowest Tax (as % of total tax revenue) of Honduras?
Provide a short and direct response. 8.59. What is the difference between the highest and the lowest Tax (as % of total tax revenue) in Pakistan?
Your response must be concise. 10.36. 